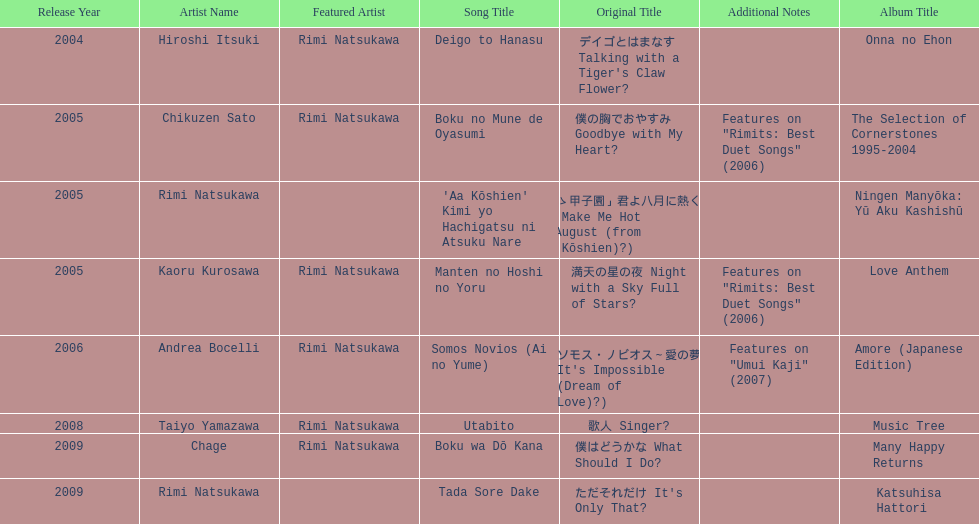Parse the full table. {'header': ['Release Year', 'Artist Name', 'Featured Artist', 'Song Title', 'Original Title', 'Additional Notes', 'Album Title'], 'rows': [['2004', 'Hiroshi Itsuki', 'Rimi Natsukawa', 'Deigo to Hanasu', "デイゴとはまなす Talking with a Tiger's Claw Flower?", '', 'Onna no Ehon'], ['2005', 'Chikuzen Sato', 'Rimi Natsukawa', 'Boku no Mune de Oyasumi', '僕の胸でおやすみ Goodbye with My Heart?', 'Features on "Rimits: Best Duet Songs" (2006)', 'The Selection of Cornerstones 1995-2004'], ['2005', 'Rimi Natsukawa', '', "'Aa Kōshien' Kimi yo Hachigatsu ni Atsuku Nare", '「あゝ甲子園」君よ八月に熱くなれ You Make Me Hot in August (from Ah, Kōshien)?)', '', 'Ningen Manyōka: Yū Aku Kashishū'], ['2005', 'Kaoru Kurosawa', 'Rimi Natsukawa', 'Manten no Hoshi no Yoru', '満天の星の夜 Night with a Sky Full of Stars?', 'Features on "Rimits: Best Duet Songs" (2006)', 'Love Anthem'], ['2006', 'Andrea Bocelli', 'Rimi Natsukawa', 'Somos Novios (Ai no Yume)', "ソモス・ノビオス～愛の夢 It's Impossible (Dream of Love)?)", 'Features on "Umui Kaji" (2007)', 'Amore (Japanese Edition)'], ['2008', 'Taiyo Yamazawa', 'Rimi Natsukawa', 'Utabito', '歌人 Singer?', '', 'Music Tree'], ['2009', 'Chage', 'Rimi Natsukawa', 'Boku wa Dō Kana', '僕はどうかな What Should I Do?', '', 'Many Happy Returns'], ['2009', 'Rimi Natsukawa', '', 'Tada Sore Dake', "ただそれだけ It's Only That?", '', 'Katsuhisa Hattori']]} What year was the first title released? 2004. 